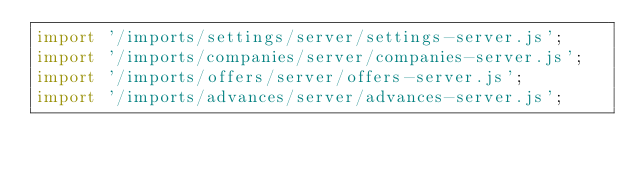<code> <loc_0><loc_0><loc_500><loc_500><_JavaScript_>import '/imports/settings/server/settings-server.js';
import '/imports/companies/server/companies-server.js';
import '/imports/offers/server/offers-server.js';
import '/imports/advances/server/advances-server.js';</code> 